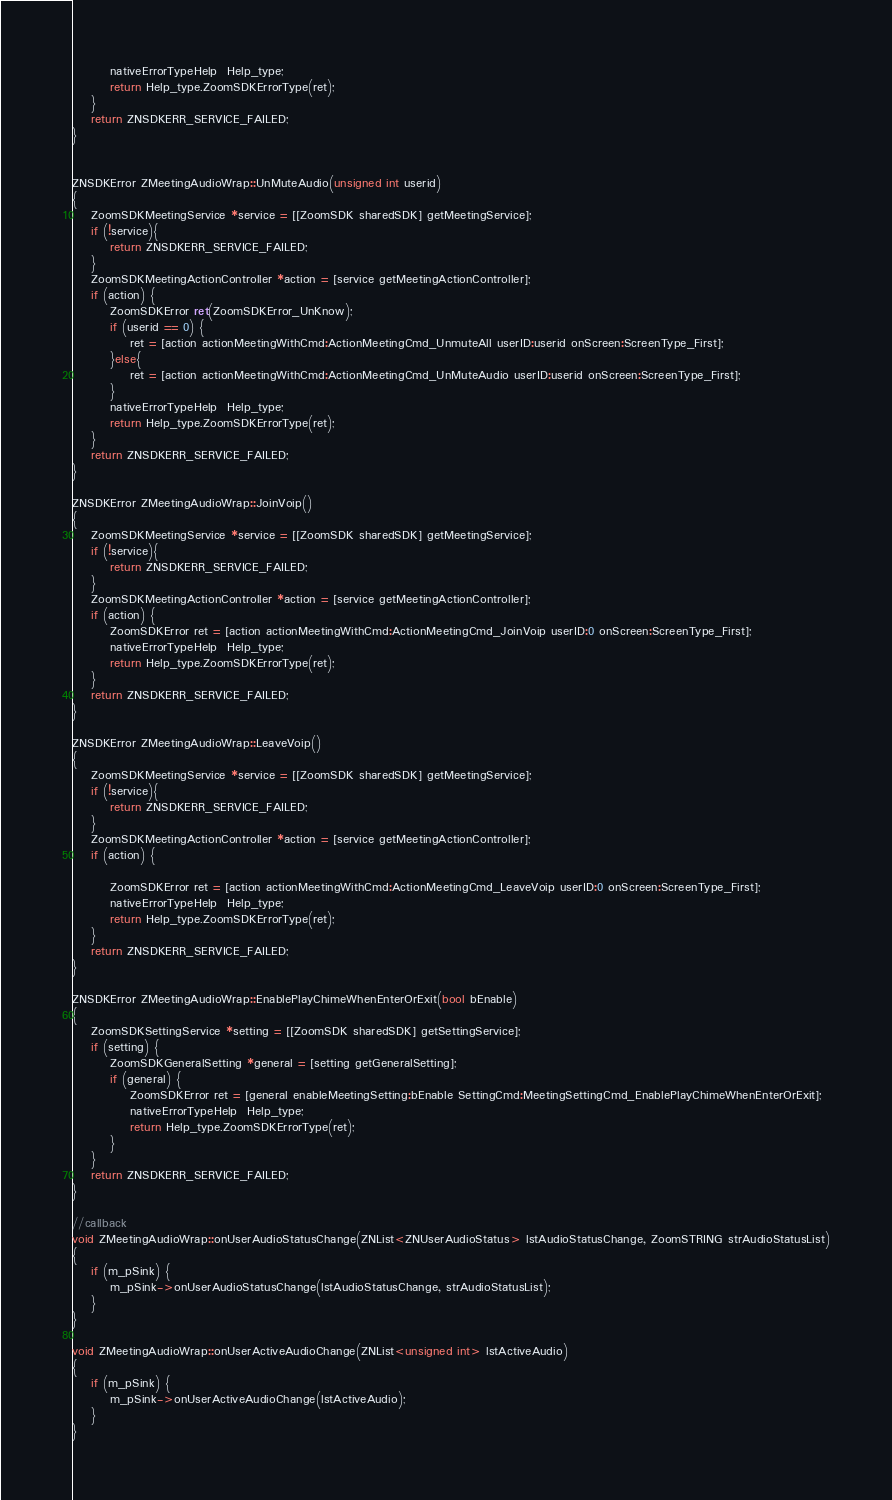<code> <loc_0><loc_0><loc_500><loc_500><_ObjectiveC_>        nativeErrorTypeHelp  Help_type;
        return Help_type.ZoomSDKErrorType(ret);
    }
    return ZNSDKERR_SERVICE_FAILED;
}


ZNSDKError ZMeetingAudioWrap::UnMuteAudio(unsigned int userid)
{
    ZoomSDKMeetingService *service = [[ZoomSDK sharedSDK] getMeetingService];
    if (!service){
        return ZNSDKERR_SERVICE_FAILED;
    }
    ZoomSDKMeetingActionController *action = [service getMeetingActionController];
    if (action) {
        ZoomSDKError ret(ZoomSDKError_UnKnow);
        if (userid == 0) {
            ret = [action actionMeetingWithCmd:ActionMeetingCmd_UnmuteAll userID:userid onScreen:ScreenType_First];
        }else{
            ret = [action actionMeetingWithCmd:ActionMeetingCmd_UnMuteAudio userID:userid onScreen:ScreenType_First];
        }
        nativeErrorTypeHelp  Help_type;
        return Help_type.ZoomSDKErrorType(ret);
    }
    return ZNSDKERR_SERVICE_FAILED;
}

ZNSDKError ZMeetingAudioWrap::JoinVoip()
{
    ZoomSDKMeetingService *service = [[ZoomSDK sharedSDK] getMeetingService];
    if (!service){
        return ZNSDKERR_SERVICE_FAILED;
    }
    ZoomSDKMeetingActionController *action = [service getMeetingActionController];
    if (action) {
        ZoomSDKError ret = [action actionMeetingWithCmd:ActionMeetingCmd_JoinVoip userID:0 onScreen:ScreenType_First];
        nativeErrorTypeHelp  Help_type;
        return Help_type.ZoomSDKErrorType(ret);
    }
    return ZNSDKERR_SERVICE_FAILED;
}

ZNSDKError ZMeetingAudioWrap::LeaveVoip()
{
    ZoomSDKMeetingService *service = [[ZoomSDK sharedSDK] getMeetingService];
    if (!service){
        return ZNSDKERR_SERVICE_FAILED;
    }
    ZoomSDKMeetingActionController *action = [service getMeetingActionController];
    if (action) {

        ZoomSDKError ret = [action actionMeetingWithCmd:ActionMeetingCmd_LeaveVoip userID:0 onScreen:ScreenType_First];
        nativeErrorTypeHelp  Help_type;
        return Help_type.ZoomSDKErrorType(ret);
    }
    return ZNSDKERR_SERVICE_FAILED;
}

ZNSDKError ZMeetingAudioWrap::EnablePlayChimeWhenEnterOrExit(bool bEnable)
{
    ZoomSDKSettingService *setting = [[ZoomSDK sharedSDK] getSettingService];
    if (setting) {
        ZoomSDKGeneralSetting *general = [setting getGeneralSetting];
        if (general) {
            ZoomSDKError ret = [general enableMeetingSetting:bEnable SettingCmd:MeetingSettingCmd_EnablePlayChimeWhenEnterOrExit];
            nativeErrorTypeHelp  Help_type;
            return Help_type.ZoomSDKErrorType(ret);
        }
    }
    return ZNSDKERR_SERVICE_FAILED;
}

//callback
void ZMeetingAudioWrap::onUserAudioStatusChange(ZNList<ZNUserAudioStatus> lstAudioStatusChange, ZoomSTRING strAudioStatusList)
{
    if (m_pSink) {
        m_pSink->onUserAudioStatusChange(lstAudioStatusChange, strAudioStatusList);
    }
}

void ZMeetingAudioWrap::onUserActiveAudioChange(ZNList<unsigned int> lstActiveAudio)
{
    if (m_pSink) {
        m_pSink->onUserActiveAudioChange(lstActiveAudio);
    }
}
</code> 